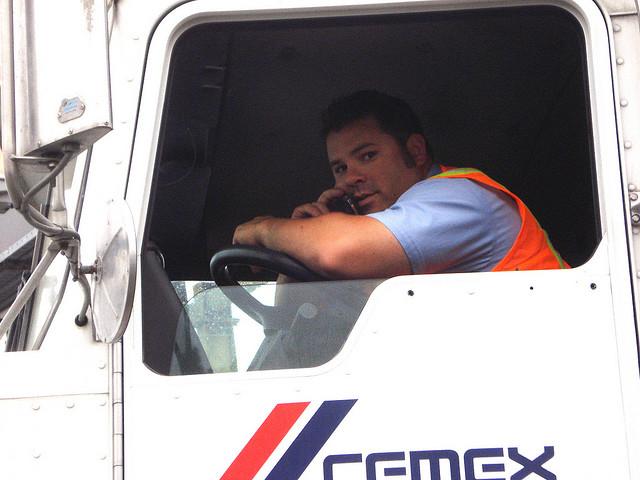What is name displayed on the door of the truck?
Concise answer only. Cemex. Is this person driving safely?
Short answer required. No. Is this guy wearing a safety vest?
Answer briefly. Yes. 